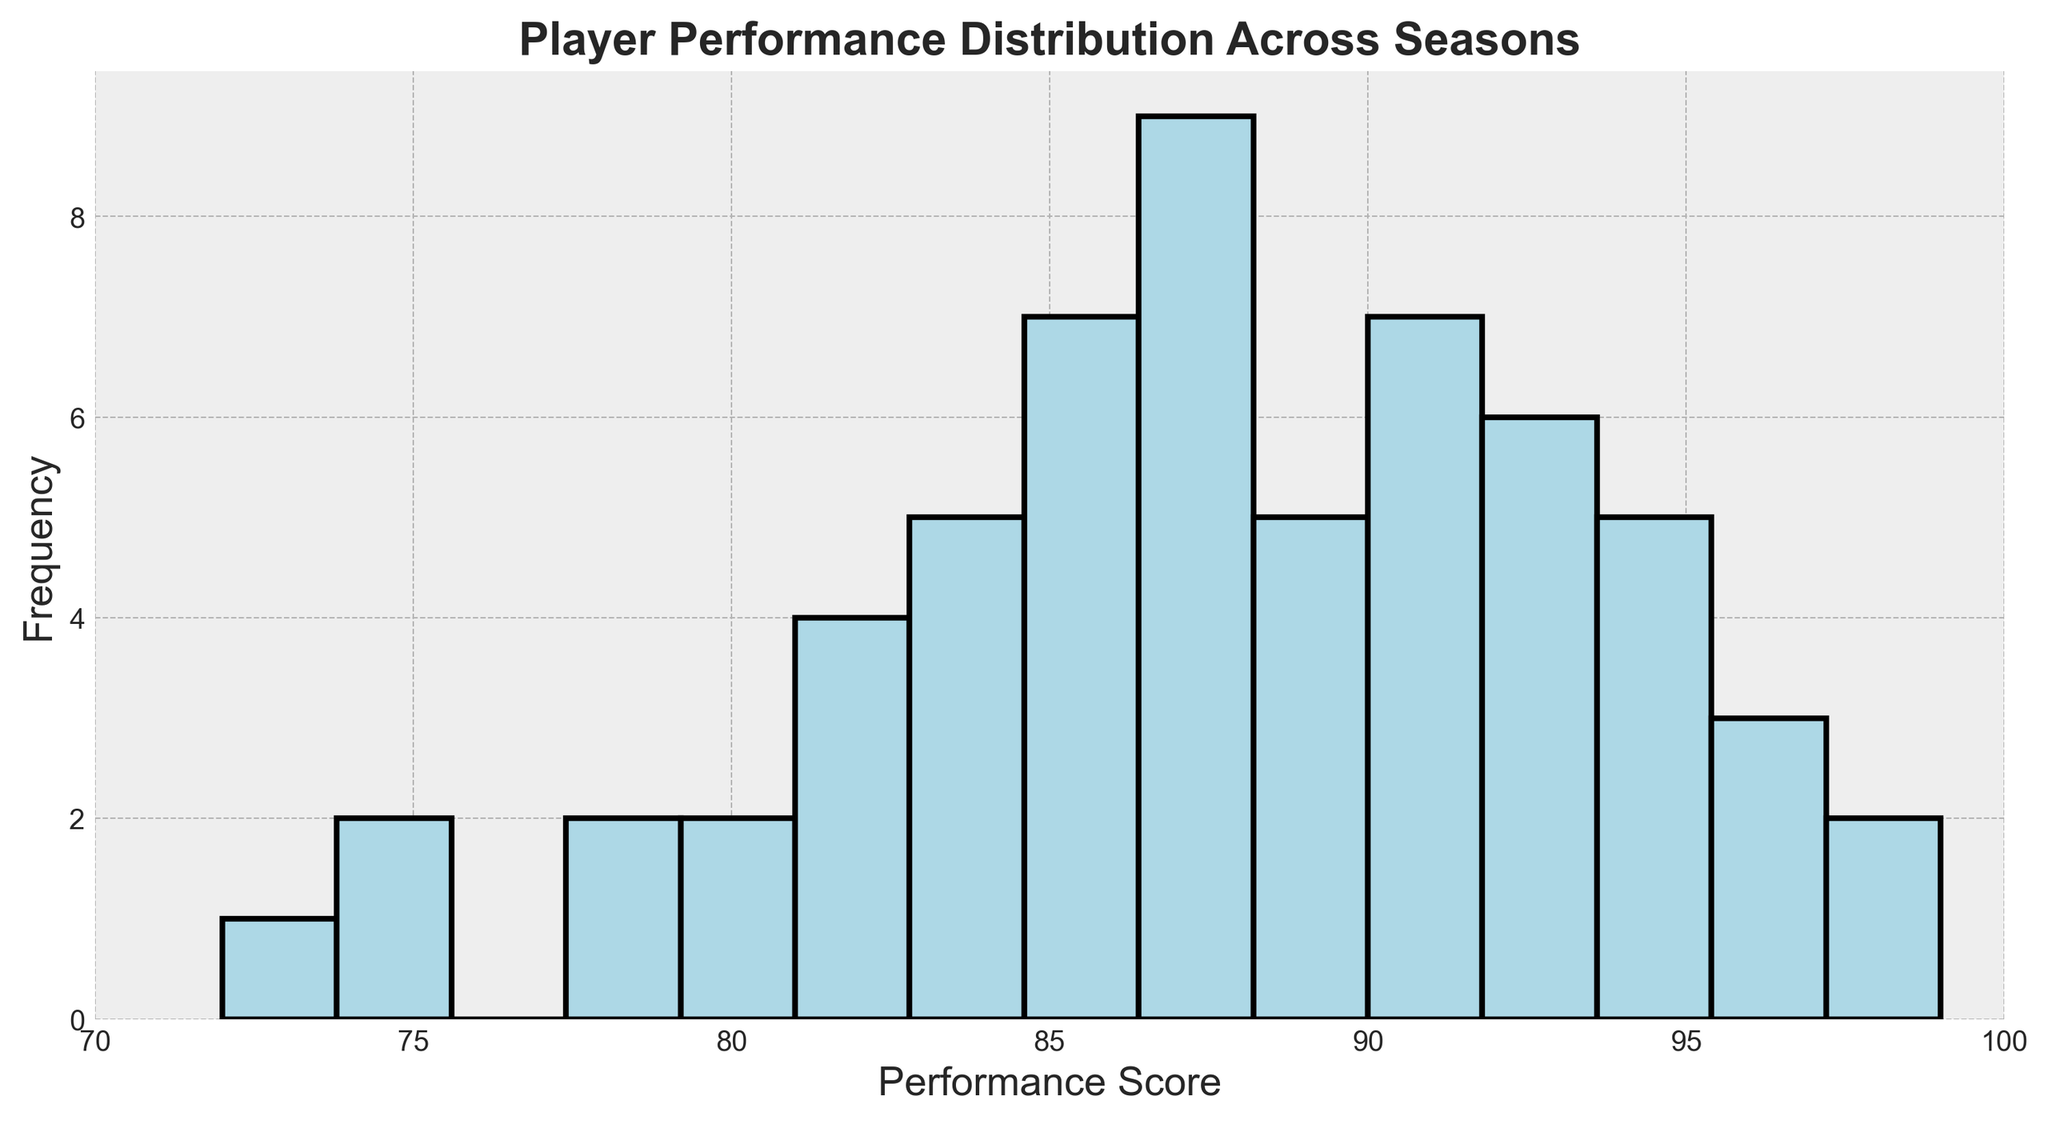What is the most frequent performance score range? Start by looking at the peak or highest bar in the histogram, which will indicate the most frequent score range. Identify the range on the x-axis where this peak occurs.
Answer: 85-90 Which performance score range has the fewest players? Locate the shortest bar in the histogram, which represents the least frequent score range. Identify this range on the x-axis.
Answer: 70-75 How many players have performance scores in the 80-85 range? Find the bar corresponding to the 80-85 range on the x-axis. Read off the height of the bar, which indicates the number of players.
Answer: 9 Is the frequency of performance scores above 90 greater than or less than the frequency of scores below 80? Sum the heights of bars for scores above 90 and compare it to the sum of the heights of bars for scores below 80.
Answer: Greater What is the visual difference between the bars representing the 75-80 range and the 95-100 range? Analyze the heights of the bars for the 75-80 and 95-100 ranges. The visual attribute to compare is the height, indicating frequency.
Answer: The 75-80 range bar is higher than the 95-100 range bar What is the average number of players per performance score range? Calculate the total number of players by summing the heights of all the bars in the histogram. Divide this sum by the number of bins (15).
Answer: 6 Between which two adjacent performance score ranges is the frequency difference the greatest? Compare the height differences of adjacent bars and identify the pair with the greatest difference.
Answer: 80-85 and 85-90 